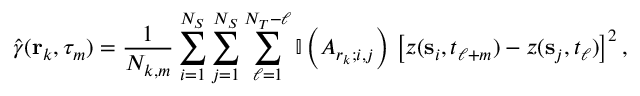Convert formula to latex. <formula><loc_0><loc_0><loc_500><loc_500>\hat { \gamma } ( { r } _ { k } , \tau _ { m } ) = \frac { 1 } { N _ { k , m } } \sum _ { i = 1 } ^ { N _ { S } } \sum _ { j = 1 } ^ { N _ { S } } \sum _ { \ell = 1 } ^ { N _ { T } - \ell } \mathbb { I } \left ( A _ { r _ { k } ; i , j } \right ) \, \left [ z ( { \mathbf s } _ { i } , t _ { \ell + m } ) - z ( { \mathbf s } _ { j } , t _ { \ell } ) \right ] ^ { 2 } ,</formula> 